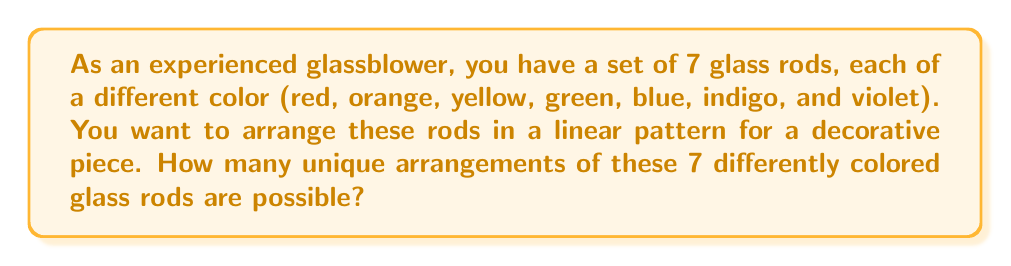Solve this math problem. To solve this problem, we can use the concept of permutations from Group theory. Since each glass rod is of a different color, and we want to arrange all of them, this is a case of permutation without repetition.

The number of permutations of n distinct objects is given by the factorial of n, denoted as n!

In this case:
- We have 7 distinct glass rods (n = 7)
- We are using all of them in each arrangement

Therefore, the number of unique arrangements is:

$$ 7! = 7 \times 6 \times 5 \times 4 \times 3 \times 2 \times 1 $$

Let's calculate this step by step:

1) $7 \times 6 = 42$
2) $42 \times 5 = 210$
3) $210 \times 4 = 840$
4) $840 \times 3 = 2,520$
5) $2,520 \times 2 = 5,040$
6) $5,040 \times 1 = 5,040$

Thus, there are 5,040 unique ways to arrange the 7 differently colored glass rods.

This result can be interpreted in the context of glassblowing as follows: for each arrangement, you have 7 choices for the first rod, then 6 for the second, 5 for the third, and so on, until you have only 1 choice for the last rod. The product of these choices gives the total number of possible arrangements.
Answer: $5,040$ unique arrangements 